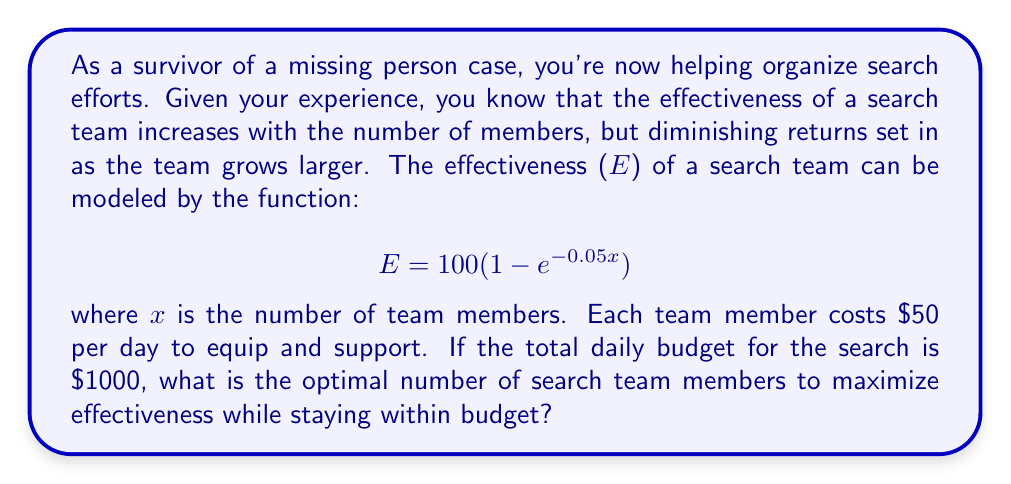Give your solution to this math problem. To solve this problem, we need to follow these steps:

1. Determine the maximum number of team members possible given the budget constraint.
2. Set up an equation to find the optimal number of team members.
3. Solve the equation using calculus or by evaluating discrete values.

Step 1: Maximum number of team members
* Daily budget: $1000
* Cost per team member: $50
* Maximum possible team members = $1000 / $50 = 20

Step 2: Set up the equation
* We need to maximize E subject to x ≤ 20
* $E = 100(1 - e^{-0.05x})$

Step 3: Solve for optimal x
In this case, since we have a discrete number of team members and a clear upper bound, we can evaluate E for each integer value of x from 1 to 20:

$$ \begin{array}{c|c}
x & E \\
\hline
1 & 4.88 \\
2 & 9.52 \\
... & ... \\
19 & 61.44 \\
20 & 63.21
\end{array} $$

We can see that E increases as x increases, reaching its maximum value within our constraint at x = 20.

If we were to solve this analytically, we would take the derivative of E with respect to x:

$$ \frac{dE}{dx} = 100(0.05e^{-0.05x}) $$

Setting this equal to zero would give us the theoretical optimal value, but it would be greater than our budget constraint. Therefore, the optimal solution within our constraints is to use all available resources.
Answer: The optimal number of search team members is 20, which utilizes the full $1000 daily budget and maximizes the team's effectiveness at 63.21%. 